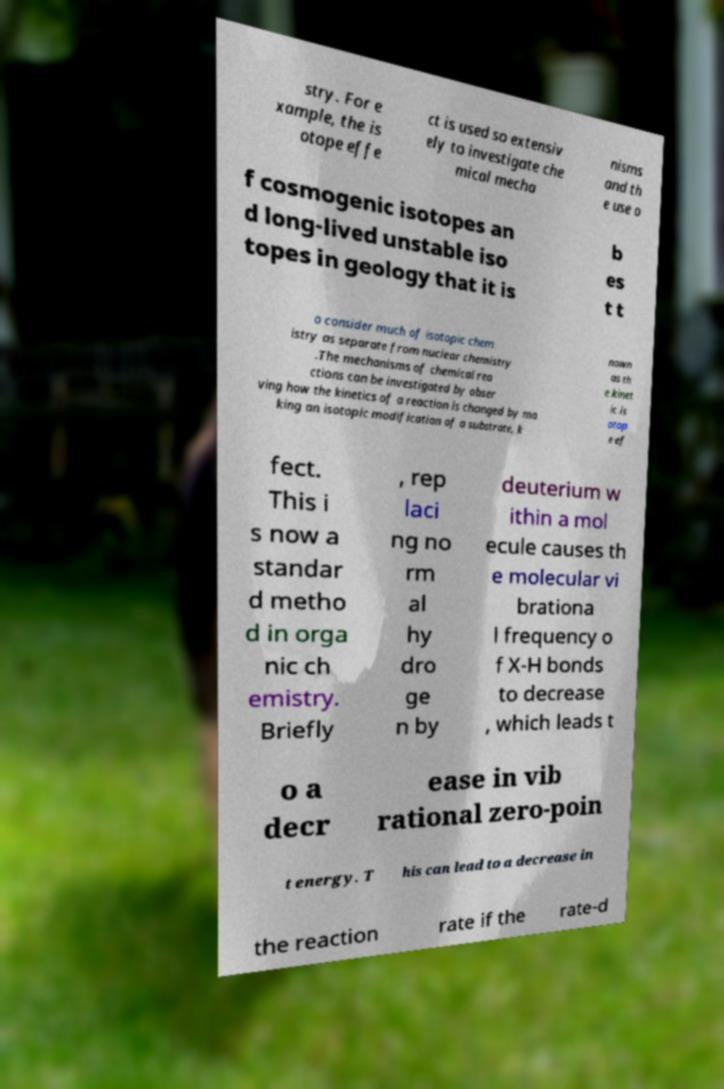Please identify and transcribe the text found in this image. stry. For e xample, the is otope effe ct is used so extensiv ely to investigate che mical mecha nisms and th e use o f cosmogenic isotopes an d long-lived unstable iso topes in geology that it is b es t t o consider much of isotopic chem istry as separate from nuclear chemistry .The mechanisms of chemical rea ctions can be investigated by obser ving how the kinetics of a reaction is changed by ma king an isotopic modification of a substrate, k nown as th e kinet ic is otop e ef fect. This i s now a standar d metho d in orga nic ch emistry. Briefly , rep laci ng no rm al hy dro ge n by deuterium w ithin a mol ecule causes th e molecular vi brationa l frequency o f X-H bonds to decrease , which leads t o a decr ease in vib rational zero-poin t energy. T his can lead to a decrease in the reaction rate if the rate-d 